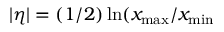<formula> <loc_0><loc_0><loc_500><loc_500>| \eta | = ( 1 / 2 ) \ln ( x _ { \max } / x _ { \min }</formula> 